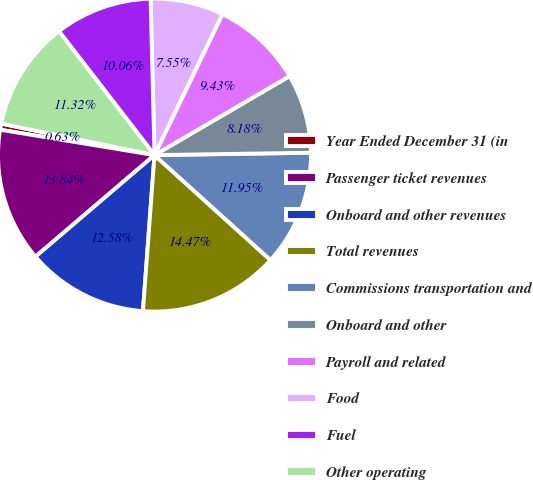Convert chart to OTSL. <chart><loc_0><loc_0><loc_500><loc_500><pie_chart><fcel>Year Ended December 31 (in<fcel>Passenger ticket revenues<fcel>Onboard and other revenues<fcel>Total revenues<fcel>Commissions transportation and<fcel>Onboard and other<fcel>Payroll and related<fcel>Food<fcel>Fuel<fcel>Other operating<nl><fcel>0.63%<fcel>13.84%<fcel>12.58%<fcel>14.47%<fcel>11.95%<fcel>8.18%<fcel>9.43%<fcel>7.55%<fcel>10.06%<fcel>11.32%<nl></chart> 